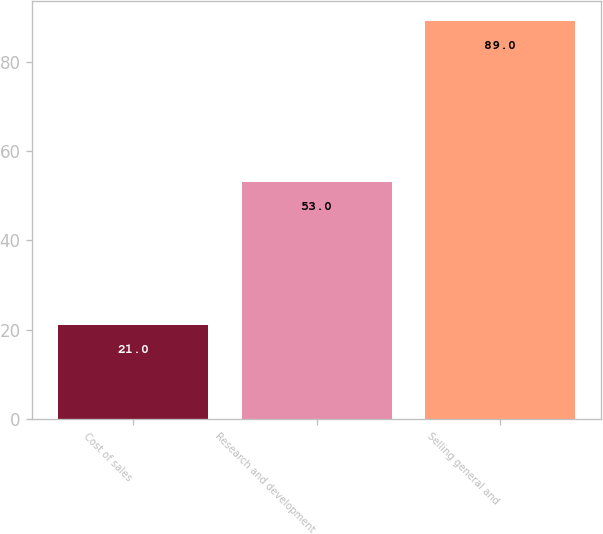<chart> <loc_0><loc_0><loc_500><loc_500><bar_chart><fcel>Cost of sales<fcel>Research and development<fcel>Selling general and<nl><fcel>21<fcel>53<fcel>89<nl></chart> 